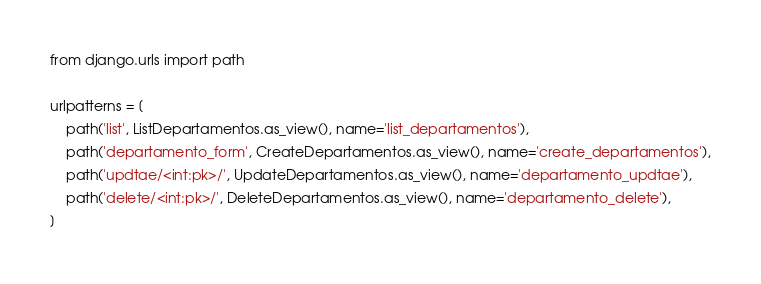<code> <loc_0><loc_0><loc_500><loc_500><_Python_>from django.urls import path

urlpatterns = [
    path('list', ListDepartamentos.as_view(), name='list_departamentos'),
    path('departamento_form', CreateDepartamentos.as_view(), name='create_departamentos'),
    path('updtae/<int:pk>/', UpdateDepartamentos.as_view(), name='departamento_updtae'),
    path('delete/<int:pk>/', DeleteDepartamentos.as_view(), name='departamento_delete'),
]
</code> 